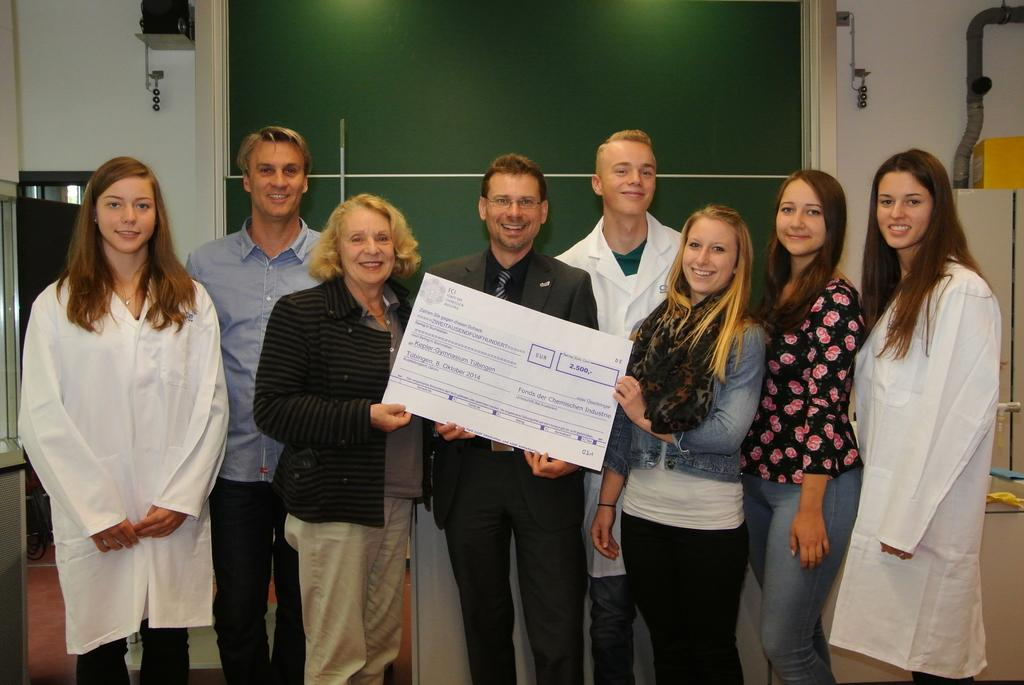How many people are in the image? There is a group of people in the image. What is the facial expression of the people in the image? The people are smiling. What are three people holding in the image? Three people are holding a cheque. What can be seen in the background of the image? There is a green wall, a speaker, and a pipe in the background. What type of school can be seen in the image? There is no school present in the image. 